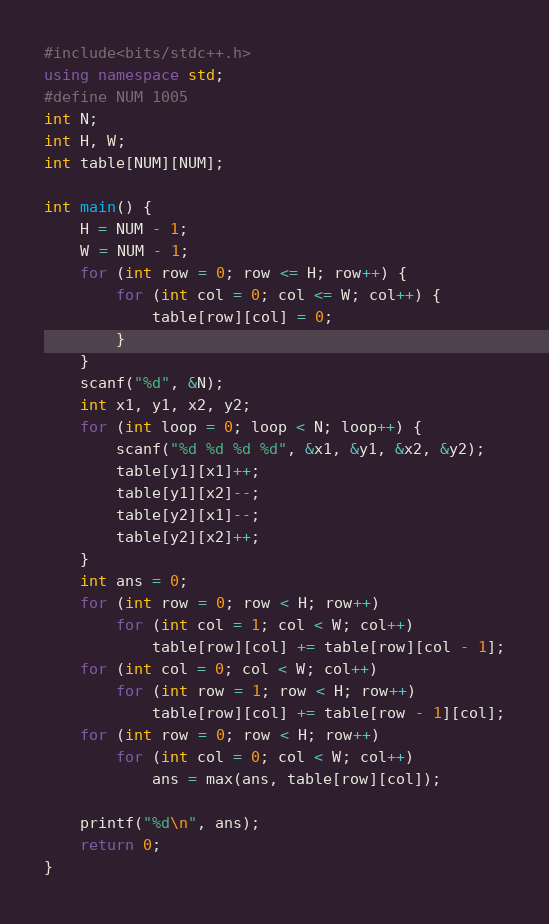Convert code to text. <code><loc_0><loc_0><loc_500><loc_500><_C++_>#include<bits/stdc++.h>
using namespace std;
#define NUM 1005
int N;
int H, W;
int table[NUM][NUM];

int main() {
	H = NUM - 1;
	W = NUM - 1;
	for (int row = 0; row <= H; row++) {
		for (int col = 0; col <= W; col++) {
			table[row][col] = 0;
		}
	}
	scanf("%d", &N);
	int x1, y1, x2, y2;
	for (int loop = 0; loop < N; loop++) {
		scanf("%d %d %d %d", &x1, &y1, &x2, &y2);
		table[y1][x1]++;
		table[y1][x2]--;
		table[y2][x1]--;
		table[y2][x2]++;
	}
	int ans = 0;
	for (int row = 0; row < H; row++) 
		for (int col = 1; col < W; col++) 
			table[row][col] += table[row][col - 1];
	for (int col = 0; col < W; col++) 
		for (int row = 1; row < H; row++) 
			table[row][col] += table[row - 1][col];
	for (int row = 0; row < H; row++) 
		for (int col = 0; col < W; col++) 
			ans = max(ans, table[row][col]);

	printf("%d\n", ans);
	return 0;
}


</code> 